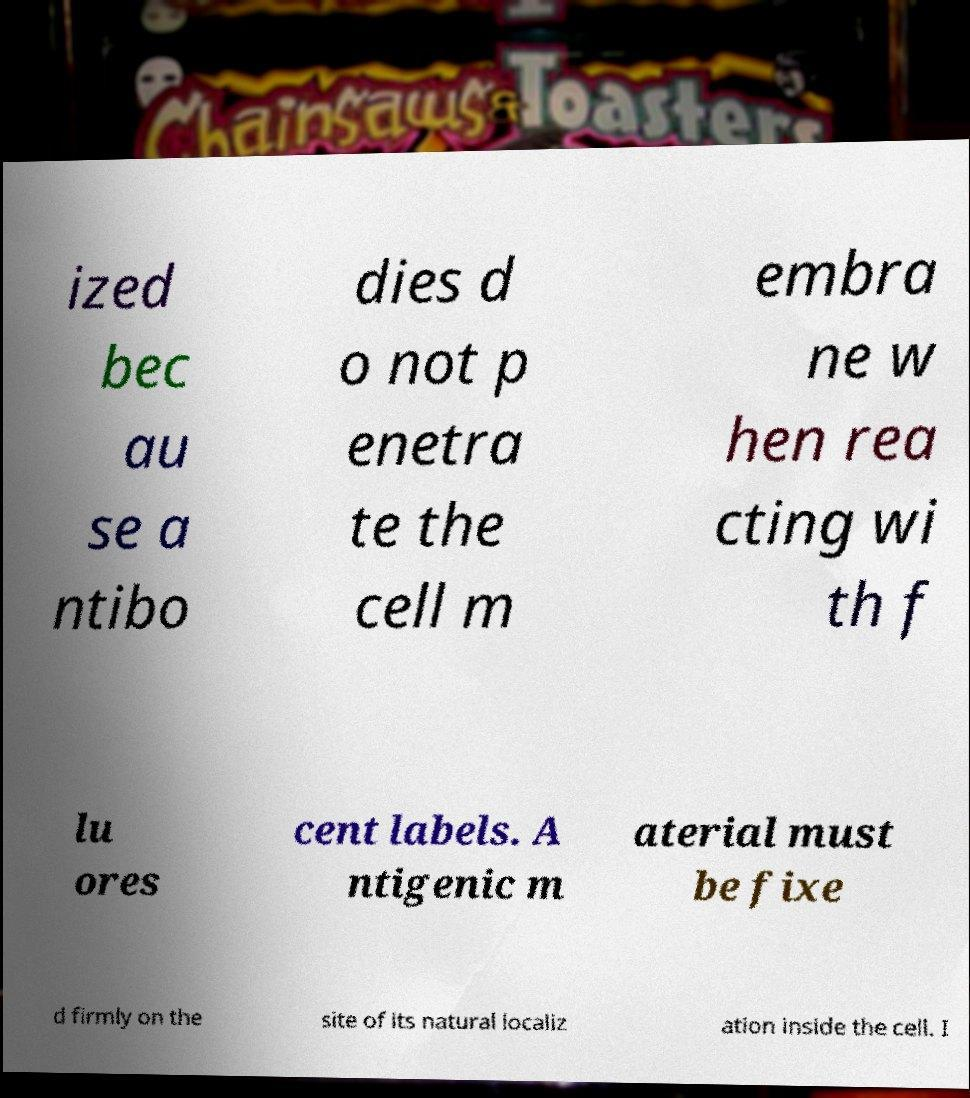There's text embedded in this image that I need extracted. Can you transcribe it verbatim? ized bec au se a ntibo dies d o not p enetra te the cell m embra ne w hen rea cting wi th f lu ores cent labels. A ntigenic m aterial must be fixe d firmly on the site of its natural localiz ation inside the cell. I 